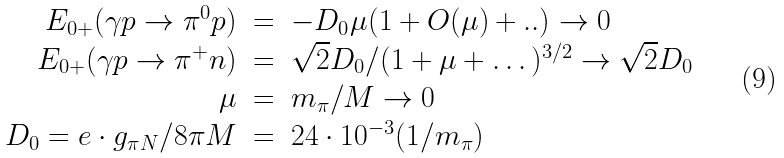<formula> <loc_0><loc_0><loc_500><loc_500>\begin{array} { r c l } E _ { 0 + } ( \gamma p \rightarrow \pi ^ { 0 } p ) & = & - D _ { 0 } \mu ( 1 + O ( \mu ) + . . ) \rightarrow 0 \\ E _ { 0 + } ( \gamma p \rightarrow \pi ^ { + } n ) & = & \sqrt { 2 } D _ { 0 } / ( 1 + \mu + \dots ) ^ { 3 / 2 } \rightarrow \sqrt { 2 } D _ { 0 } \\ \mu & = & m _ { \pi } / M \rightarrow 0 \\ D _ { 0 } = e \cdot g _ { \pi N } / 8 \pi M & = & 2 4 \cdot 1 0 ^ { - 3 } ( 1 / m _ { \pi } ) \\ \end{array}</formula> 